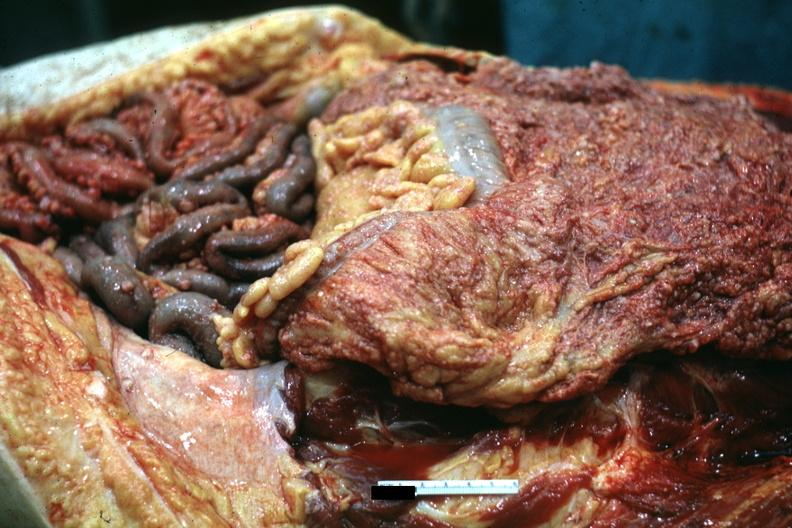does omentum show opened abdominal cavity with extensive tumor implants on omentum and bowel?
Answer the question using a single word or phrase. No 